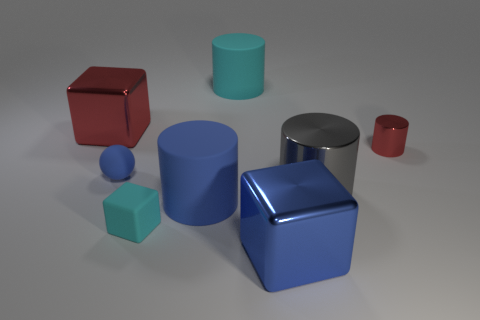Subtract all red shiny cubes. How many cubes are left? 2 Add 1 large brown shiny things. How many objects exist? 9 Subtract all cyan cylinders. How many cylinders are left? 3 Subtract all cyan cylinders. Subtract all green cubes. How many cylinders are left? 3 Subtract 1 red cylinders. How many objects are left? 7 Subtract all balls. How many objects are left? 7 Subtract 2 blocks. How many blocks are left? 1 Subtract all gray blocks. How many cyan cylinders are left? 1 Subtract all small blue cylinders. Subtract all blue metal things. How many objects are left? 7 Add 7 tiny red things. How many tiny red things are left? 8 